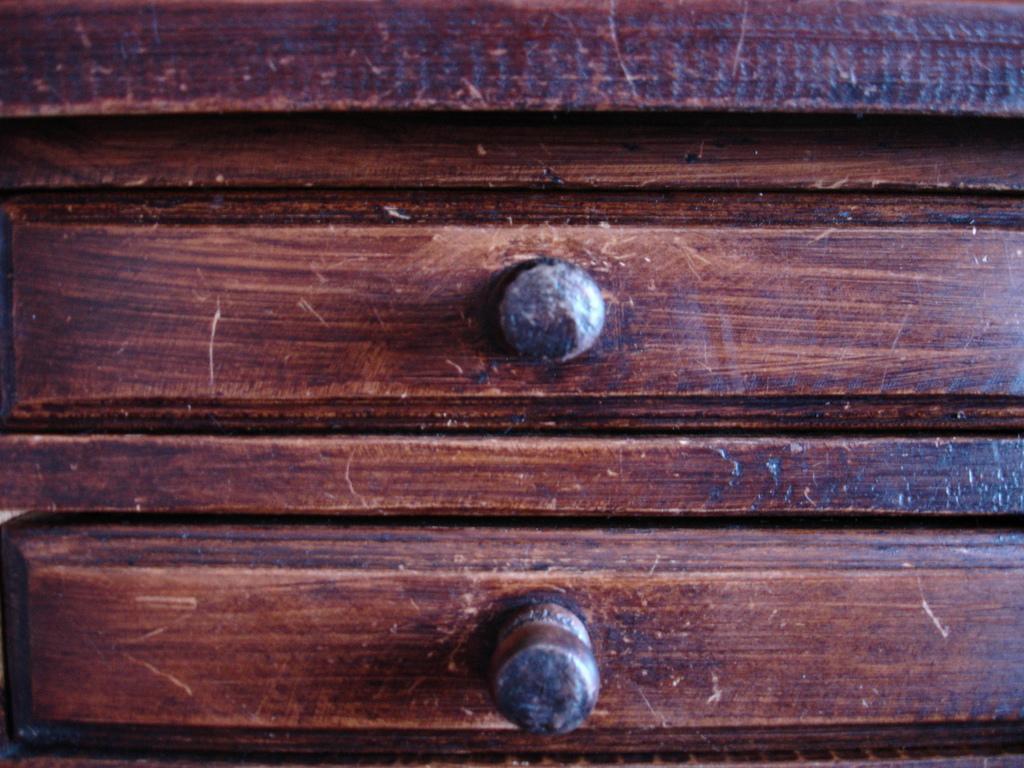In one or two sentences, can you explain what this image depicts? In this image I can see brown colour wood and on it I can see bolts. 